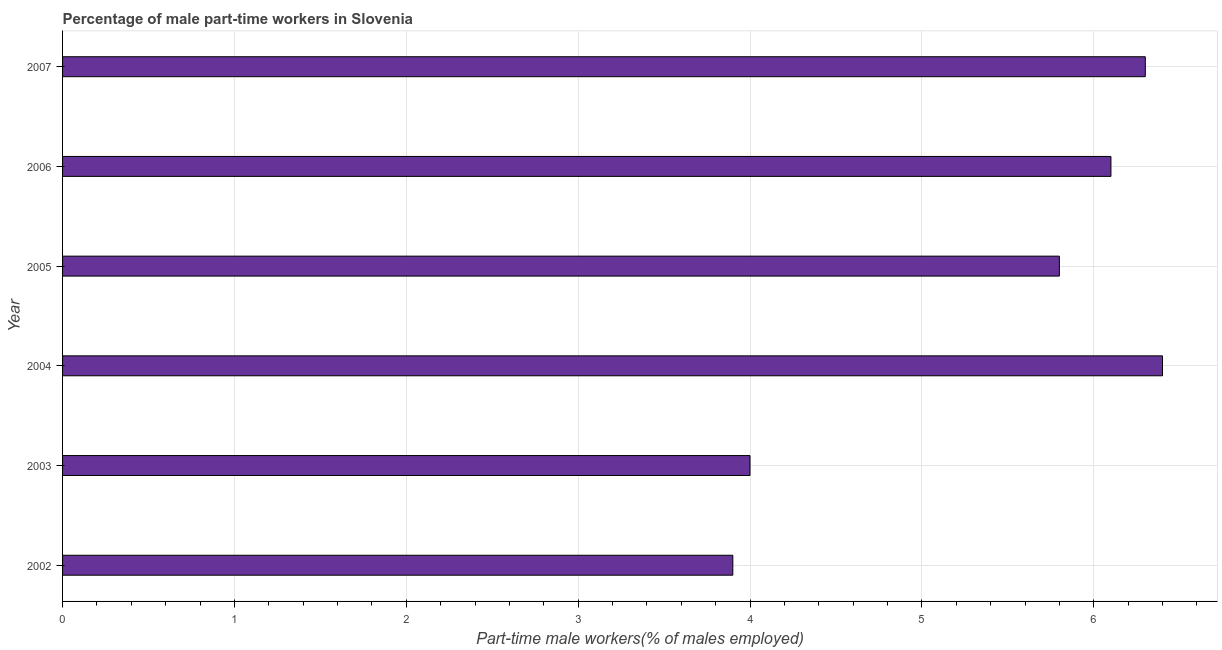Does the graph contain grids?
Give a very brief answer. Yes. What is the title of the graph?
Your response must be concise. Percentage of male part-time workers in Slovenia. What is the label or title of the X-axis?
Your answer should be compact. Part-time male workers(% of males employed). What is the label or title of the Y-axis?
Make the answer very short. Year. What is the percentage of part-time male workers in 2004?
Keep it short and to the point. 6.4. Across all years, what is the maximum percentage of part-time male workers?
Keep it short and to the point. 6.4. Across all years, what is the minimum percentage of part-time male workers?
Offer a very short reply. 3.9. In which year was the percentage of part-time male workers maximum?
Your answer should be very brief. 2004. In which year was the percentage of part-time male workers minimum?
Make the answer very short. 2002. What is the sum of the percentage of part-time male workers?
Your answer should be very brief. 32.5. What is the difference between the percentage of part-time male workers in 2004 and 2007?
Your answer should be compact. 0.1. What is the average percentage of part-time male workers per year?
Make the answer very short. 5.42. What is the median percentage of part-time male workers?
Your answer should be compact. 5.95. In how many years, is the percentage of part-time male workers greater than 6 %?
Keep it short and to the point. 3. What is the ratio of the percentage of part-time male workers in 2002 to that in 2007?
Offer a very short reply. 0.62. Is the percentage of part-time male workers in 2003 less than that in 2006?
Give a very brief answer. Yes. What is the difference between the highest and the second highest percentage of part-time male workers?
Provide a short and direct response. 0.1. What is the difference between the highest and the lowest percentage of part-time male workers?
Your answer should be very brief. 2.5. How many bars are there?
Ensure brevity in your answer.  6. Are all the bars in the graph horizontal?
Provide a succinct answer. Yes. How many years are there in the graph?
Provide a short and direct response. 6. What is the difference between two consecutive major ticks on the X-axis?
Ensure brevity in your answer.  1. Are the values on the major ticks of X-axis written in scientific E-notation?
Your response must be concise. No. What is the Part-time male workers(% of males employed) in 2002?
Ensure brevity in your answer.  3.9. What is the Part-time male workers(% of males employed) in 2004?
Your answer should be very brief. 6.4. What is the Part-time male workers(% of males employed) in 2005?
Provide a succinct answer. 5.8. What is the Part-time male workers(% of males employed) in 2006?
Give a very brief answer. 6.1. What is the Part-time male workers(% of males employed) in 2007?
Keep it short and to the point. 6.3. What is the difference between the Part-time male workers(% of males employed) in 2002 and 2005?
Your answer should be very brief. -1.9. What is the difference between the Part-time male workers(% of males employed) in 2003 and 2005?
Offer a terse response. -1.8. What is the difference between the Part-time male workers(% of males employed) in 2003 and 2006?
Keep it short and to the point. -2.1. What is the difference between the Part-time male workers(% of males employed) in 2004 and 2005?
Your answer should be compact. 0.6. What is the difference between the Part-time male workers(% of males employed) in 2004 and 2006?
Provide a succinct answer. 0.3. What is the difference between the Part-time male workers(% of males employed) in 2005 and 2007?
Provide a succinct answer. -0.5. What is the difference between the Part-time male workers(% of males employed) in 2006 and 2007?
Offer a very short reply. -0.2. What is the ratio of the Part-time male workers(% of males employed) in 2002 to that in 2003?
Your response must be concise. 0.97. What is the ratio of the Part-time male workers(% of males employed) in 2002 to that in 2004?
Offer a very short reply. 0.61. What is the ratio of the Part-time male workers(% of males employed) in 2002 to that in 2005?
Make the answer very short. 0.67. What is the ratio of the Part-time male workers(% of males employed) in 2002 to that in 2006?
Your answer should be very brief. 0.64. What is the ratio of the Part-time male workers(% of males employed) in 2002 to that in 2007?
Make the answer very short. 0.62. What is the ratio of the Part-time male workers(% of males employed) in 2003 to that in 2005?
Offer a very short reply. 0.69. What is the ratio of the Part-time male workers(% of males employed) in 2003 to that in 2006?
Offer a terse response. 0.66. What is the ratio of the Part-time male workers(% of males employed) in 2003 to that in 2007?
Keep it short and to the point. 0.64. What is the ratio of the Part-time male workers(% of males employed) in 2004 to that in 2005?
Give a very brief answer. 1.1. What is the ratio of the Part-time male workers(% of males employed) in 2004 to that in 2006?
Your answer should be very brief. 1.05. What is the ratio of the Part-time male workers(% of males employed) in 2004 to that in 2007?
Provide a succinct answer. 1.02. What is the ratio of the Part-time male workers(% of males employed) in 2005 to that in 2006?
Offer a very short reply. 0.95. What is the ratio of the Part-time male workers(% of males employed) in 2005 to that in 2007?
Offer a terse response. 0.92. What is the ratio of the Part-time male workers(% of males employed) in 2006 to that in 2007?
Your response must be concise. 0.97. 